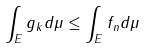Convert formula to latex. <formula><loc_0><loc_0><loc_500><loc_500>\int _ { E } g _ { k } d \mu \leq \int _ { E } f _ { n } d \mu</formula> 